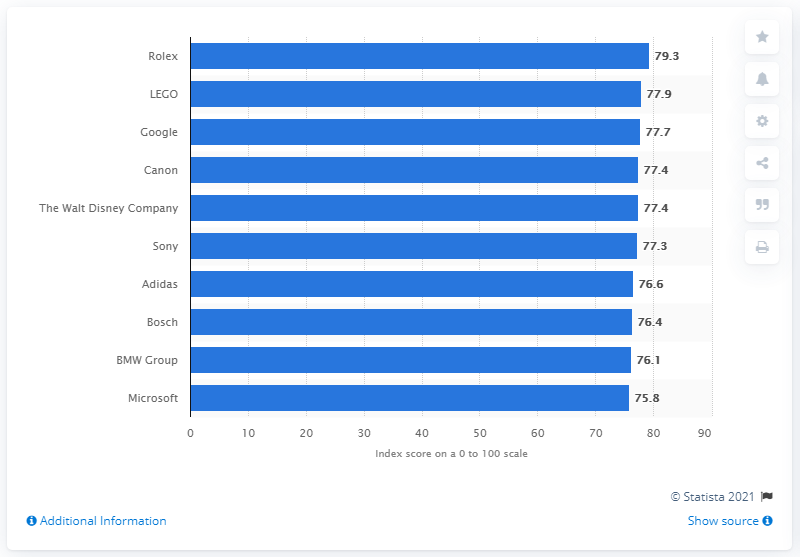Point out several critical features in this image. In the first quarter of 2018, Rolex was considered the most reputable company. 